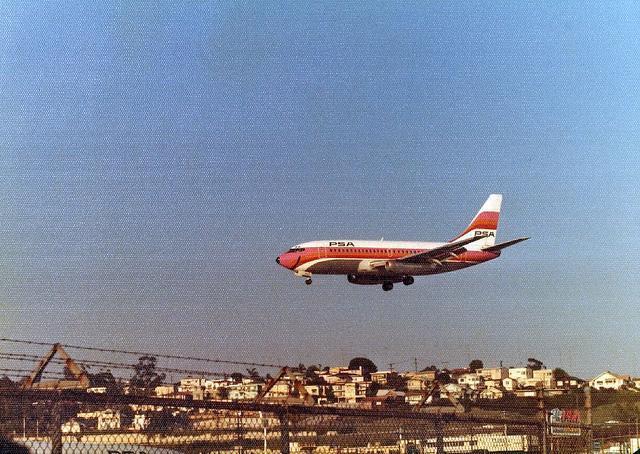How many pillows in the chair on the right?
Give a very brief answer. 0. 